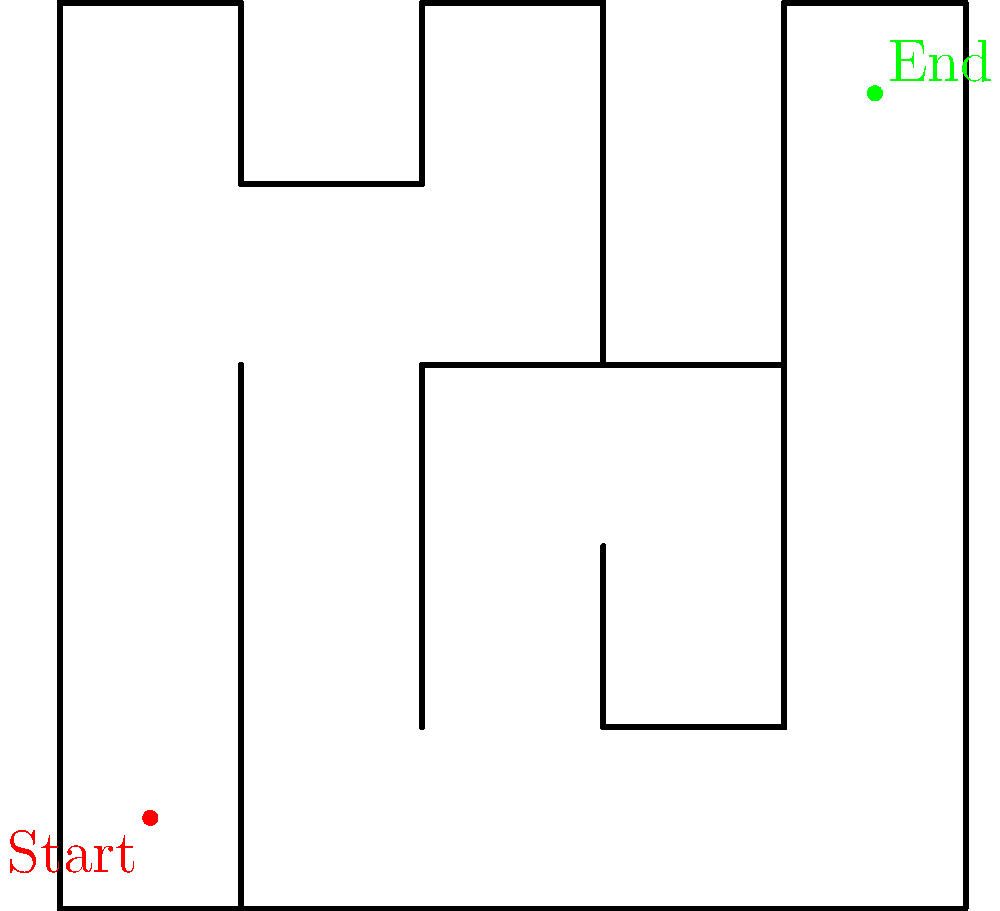Remember our childhood adventures in the park? Now imagine we're exploring a new maze together. Can you find the shortest path from the red start point to the green end point, counting the number of grid squares you need to pass through (including the start and end squares)? Let's tackle this maze together, just like we used to solve puzzles as kids:

1. Start at the red dot in the bottom-left corner.
2. Move up 3 squares to avoid the first wall.
3. Turn right and move 1 square.
4. Go up 1 square to avoid the horizontal wall.
5. Move right 2 squares to reach the center vertical passage.
6. Go up 1 square to clear the horizontal wall.
7. Turn right and move 1 square.
8. Finally, go up 1 square to reach the green end point.

Counting each square we passed through, including the start and end:
1 (start) + 3 (up) + 1 (right) + 1 (up) + 2 (right) + 1 (up) + 1 (right) + 1 (up) + 1 (end) = 12 squares total.

This is the shortest path as it avoids all obstacles and takes the most direct route possible.
Answer: 12 squares 